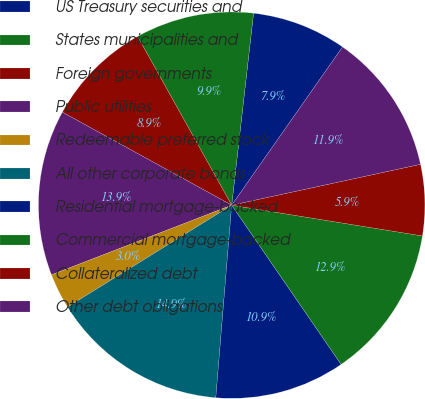Convert chart to OTSL. <chart><loc_0><loc_0><loc_500><loc_500><pie_chart><fcel>US Treasury securities and<fcel>States municipalities and<fcel>Foreign governments<fcel>Public utilities<fcel>Redeemable preferred stock<fcel>All other corporate bonds<fcel>Residential mortgage-backed<fcel>Commercial mortgage-backed<fcel>Collateralized debt<fcel>Other debt obligations<nl><fcel>7.92%<fcel>9.9%<fcel>8.91%<fcel>13.86%<fcel>2.97%<fcel>14.85%<fcel>10.89%<fcel>12.87%<fcel>5.94%<fcel>11.88%<nl></chart> 